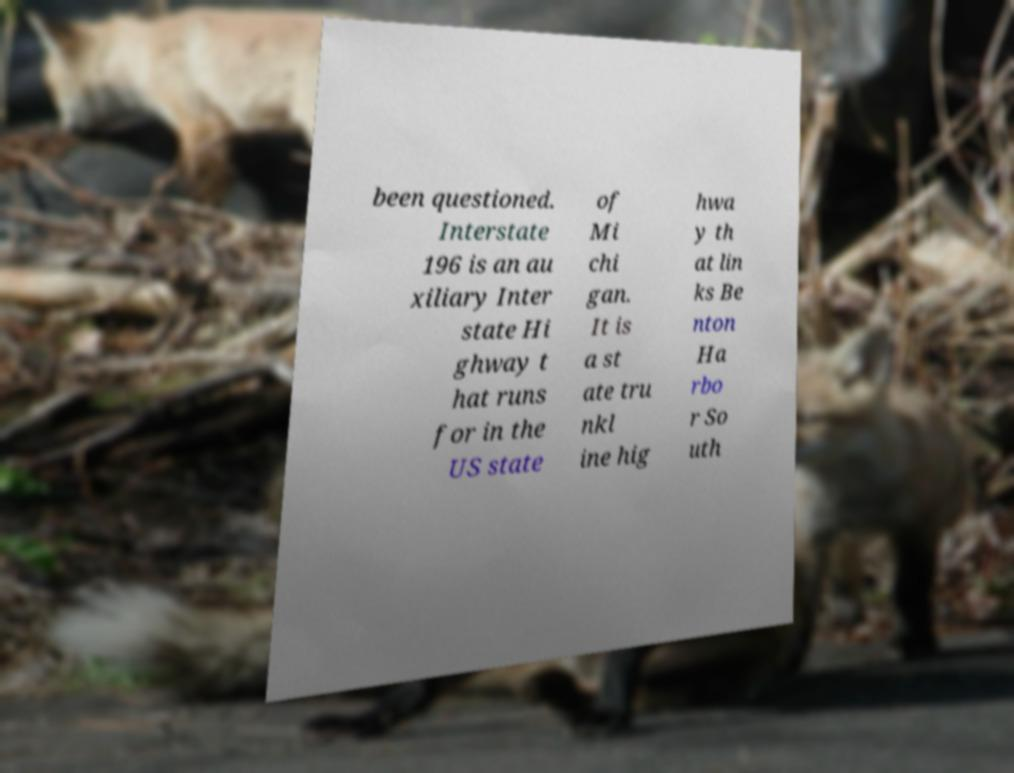Can you accurately transcribe the text from the provided image for me? been questioned. Interstate 196 is an au xiliary Inter state Hi ghway t hat runs for in the US state of Mi chi gan. It is a st ate tru nkl ine hig hwa y th at lin ks Be nton Ha rbo r So uth 